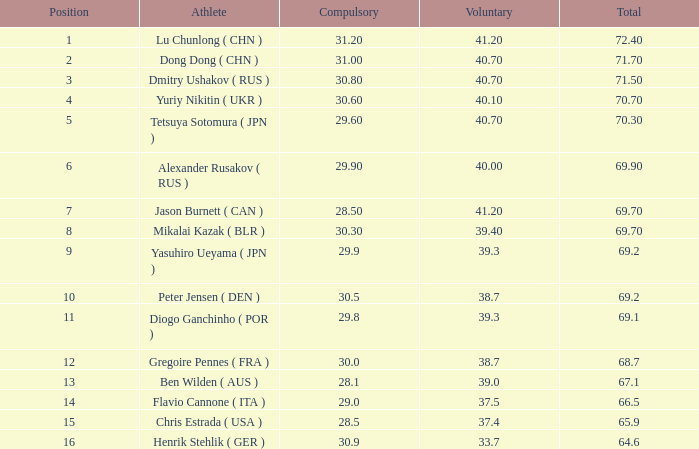Give me the full table as a dictionary. {'header': ['Position', 'Athlete', 'Compulsory', 'Voluntary', 'Total'], 'rows': [['1', 'Lu Chunlong ( CHN )', '31.20', '41.20', '72.40'], ['2', 'Dong Dong ( CHN )', '31.00', '40.70', '71.70'], ['3', 'Dmitry Ushakov ( RUS )', '30.80', '40.70', '71.50'], ['4', 'Yuriy Nikitin ( UKR )', '30.60', '40.10', '70.70'], ['5', 'Tetsuya Sotomura ( JPN )', '29.60', '40.70', '70.30'], ['6', 'Alexander Rusakov ( RUS )', '29.90', '40.00', '69.90'], ['7', 'Jason Burnett ( CAN )', '28.50', '41.20', '69.70'], ['8', 'Mikalai Kazak ( BLR )', '30.30', '39.40', '69.70'], ['9', 'Yasuhiro Ueyama ( JPN )', '29.9', '39.3', '69.2'], ['10', 'Peter Jensen ( DEN )', '30.5', '38.7', '69.2'], ['11', 'Diogo Ganchinho ( POR )', '29.8', '39.3', '69.1'], ['12', 'Gregoire Pennes ( FRA )', '30.0', '38.7', '68.7'], ['13', 'Ben Wilden ( AUS )', '28.1', '39.0', '67.1'], ['14', 'Flavio Cannone ( ITA )', '29.0', '37.5', '66.5'], ['15', 'Chris Estrada ( USA )', '28.5', '37.4', '65.9'], ['16', 'Henrik Stehlik ( GER )', '30.9', '33.7', '64.6']]} What's the total of the position of 1? None. 